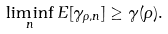Convert formula to latex. <formula><loc_0><loc_0><loc_500><loc_500>\liminf _ { n } E [ \gamma _ { \rho , n } ] \geq \gamma ( \rho ) .</formula> 